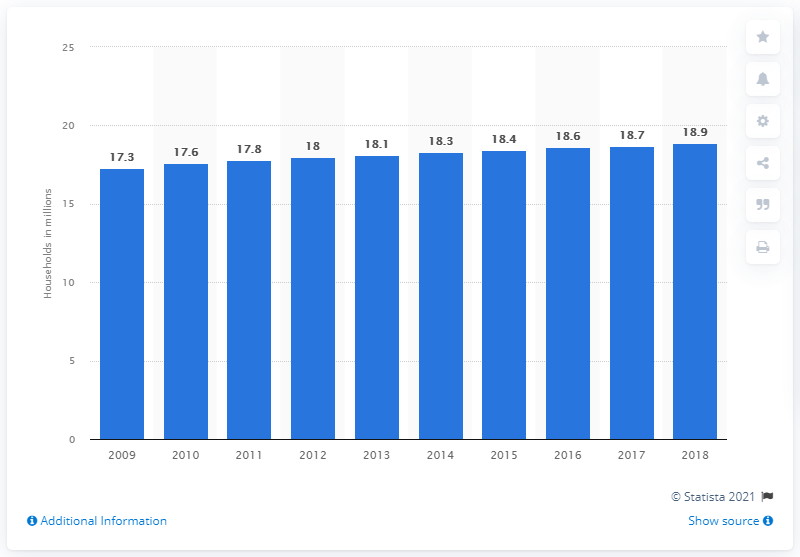List a handful of essential elements in this visual. In 2014, there were 18.4 TV owning households in Spain. 